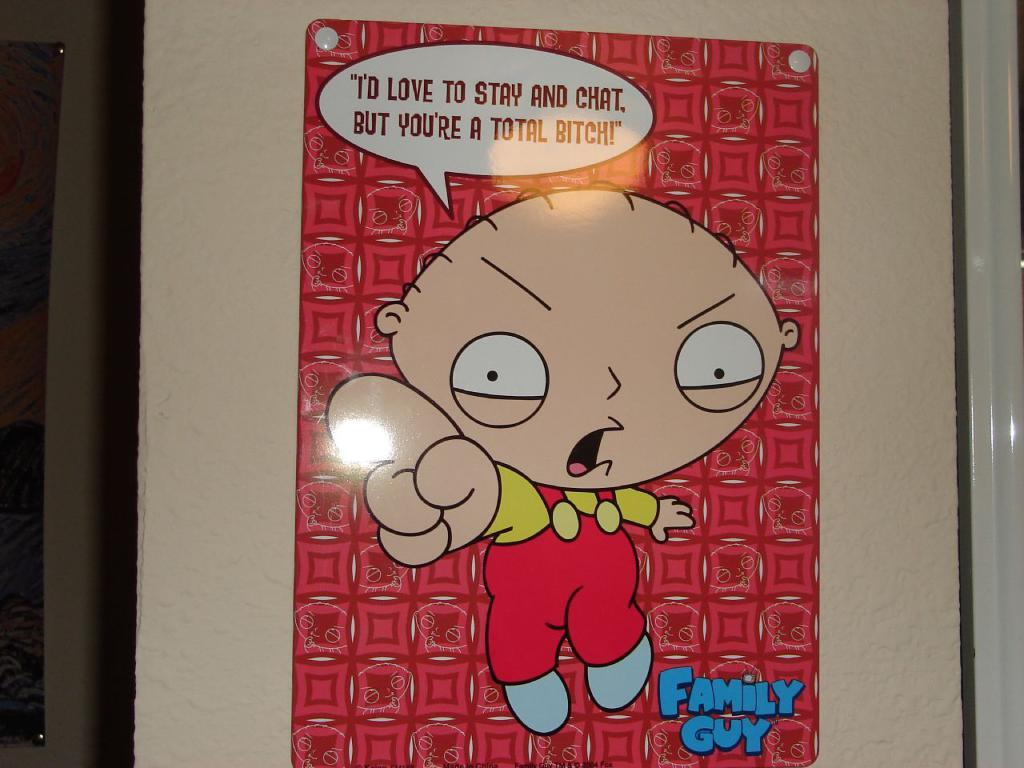What is on the wall in the image? There is a poster on the wall in the image. What type of picture is featured on the poster? The poster contains an animated picture. How much tax is being paid on the poster in the image? There is no mention of tax in the image, as it features a poster with an animated picture. 